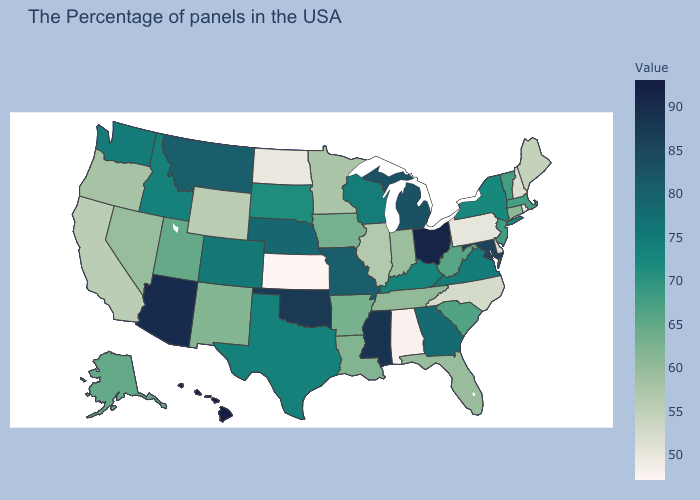Does Florida have the lowest value in the USA?
Give a very brief answer. No. Which states have the lowest value in the USA?
Be succinct. Kansas. Does Massachusetts have a higher value than Connecticut?
Write a very short answer. Yes. Among the states that border Louisiana , does Texas have the highest value?
Keep it brief. No. Which states have the lowest value in the South?
Write a very short answer. Alabama. Which states have the lowest value in the USA?
Answer briefly. Kansas. Is the legend a continuous bar?
Give a very brief answer. Yes. 